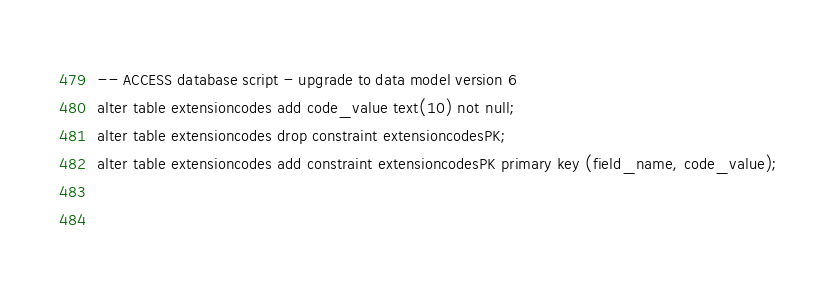<code> <loc_0><loc_0><loc_500><loc_500><_SQL_>-- ACCESS database script - upgrade to data model version 6
alter table extensioncodes add code_value text(10) not null;
alter table extensioncodes drop constraint extensioncodesPK;
alter table extensioncodes add constraint extensioncodesPK primary key (field_name, code_value);
 
 



</code> 